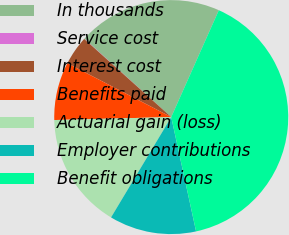<chart> <loc_0><loc_0><loc_500><loc_500><pie_chart><fcel>In thousands<fcel>Service cost<fcel>Interest cost<fcel>Benefits paid<fcel>Actuarial gain (loss)<fcel>Employer contributions<fcel>Benefit obligations<nl><fcel>19.99%<fcel>0.04%<fcel>4.03%<fcel>8.02%<fcel>16.0%<fcel>12.01%<fcel>39.93%<nl></chart> 